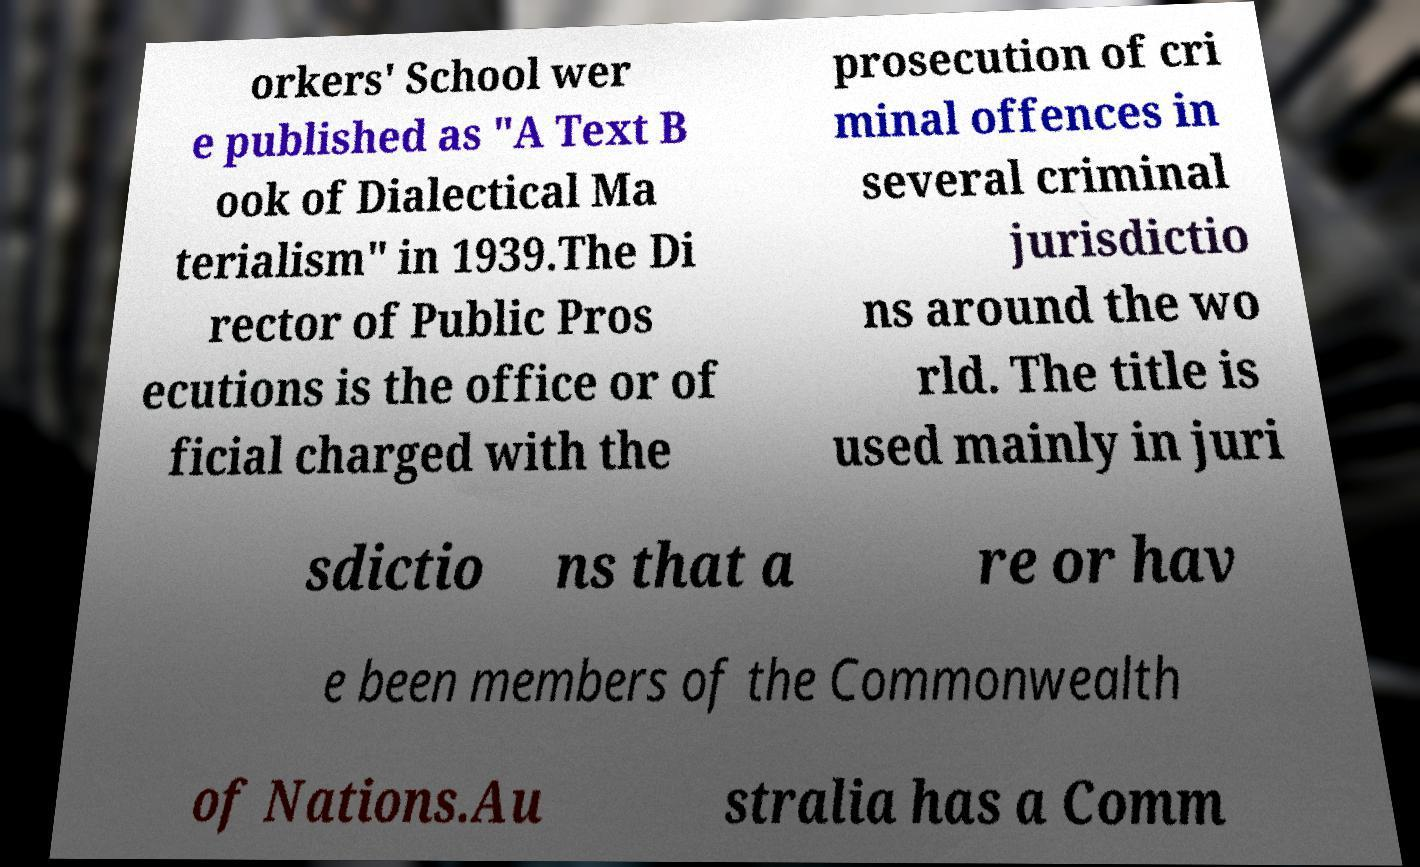Please read and relay the text visible in this image. What does it say? orkers' School wer e published as "A Text B ook of Dialectical Ma terialism" in 1939.The Di rector of Public Pros ecutions is the office or of ficial charged with the prosecution of cri minal offences in several criminal jurisdictio ns around the wo rld. The title is used mainly in juri sdictio ns that a re or hav e been members of the Commonwealth of Nations.Au stralia has a Comm 